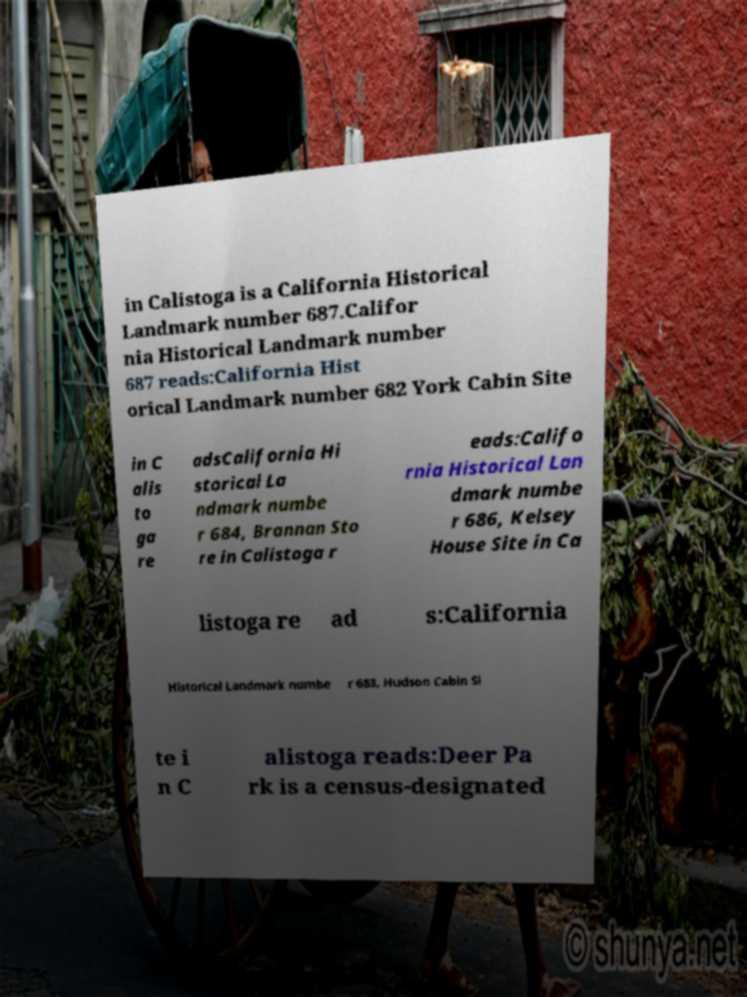What messages or text are displayed in this image? I need them in a readable, typed format. in Calistoga is a California Historical Landmark number 687.Califor nia Historical Landmark number 687 reads:California Hist orical Landmark number 682 York Cabin Site in C alis to ga re adsCalifornia Hi storical La ndmark numbe r 684, Brannan Sto re in Calistoga r eads:Califo rnia Historical Lan dmark numbe r 686, Kelsey House Site in Ca listoga re ad s:California Historical Landmark numbe r 683, Hudson Cabin Si te i n C alistoga reads:Deer Pa rk is a census-designated 